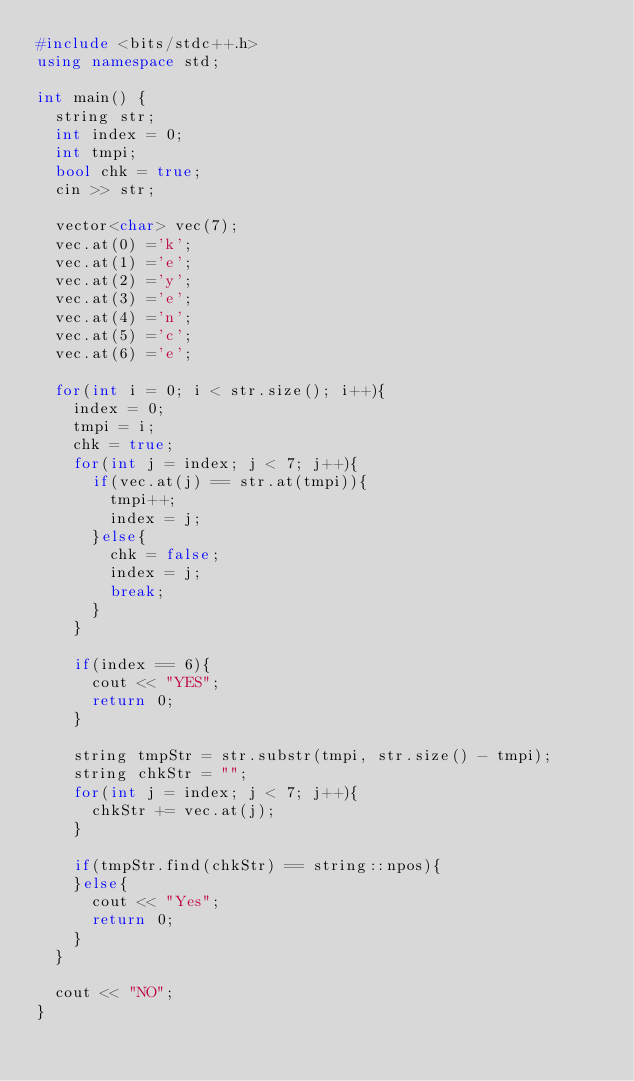Convert code to text. <code><loc_0><loc_0><loc_500><loc_500><_C++_>#include <bits/stdc++.h>
using namespace std;

int main() {
  string str;
  int index = 0;
  int tmpi;
  bool chk = true;
  cin >> str;
  
  vector<char> vec(7);
  vec.at(0) ='k';
  vec.at(1) ='e';
  vec.at(2) ='y';
  vec.at(3) ='e';
  vec.at(4) ='n';
  vec.at(5) ='c';
  vec.at(6) ='e';

  for(int i = 0; i < str.size(); i++){
    index = 0;
    tmpi = i;
    chk = true;
    for(int j = index; j < 7; j++){
      if(vec.at(j) == str.at(tmpi)){
        tmpi++;
        index = j;
      }else{
        chk = false;
        index = j;
        break;
      }
    }
    
    if(index == 6){
      cout << "YES";
      return 0;
    }
    
    string tmpStr = str.substr(tmpi, str.size() - tmpi);
    string chkStr = "";
    for(int j = index; j < 7; j++){
      chkStr += vec.at(j);
    }
    
    if(tmpStr.find(chkStr) == string::npos){
    }else{
      cout << "Yes";
      return 0;
    }
  }
  
  cout << "NO";     
}
</code> 